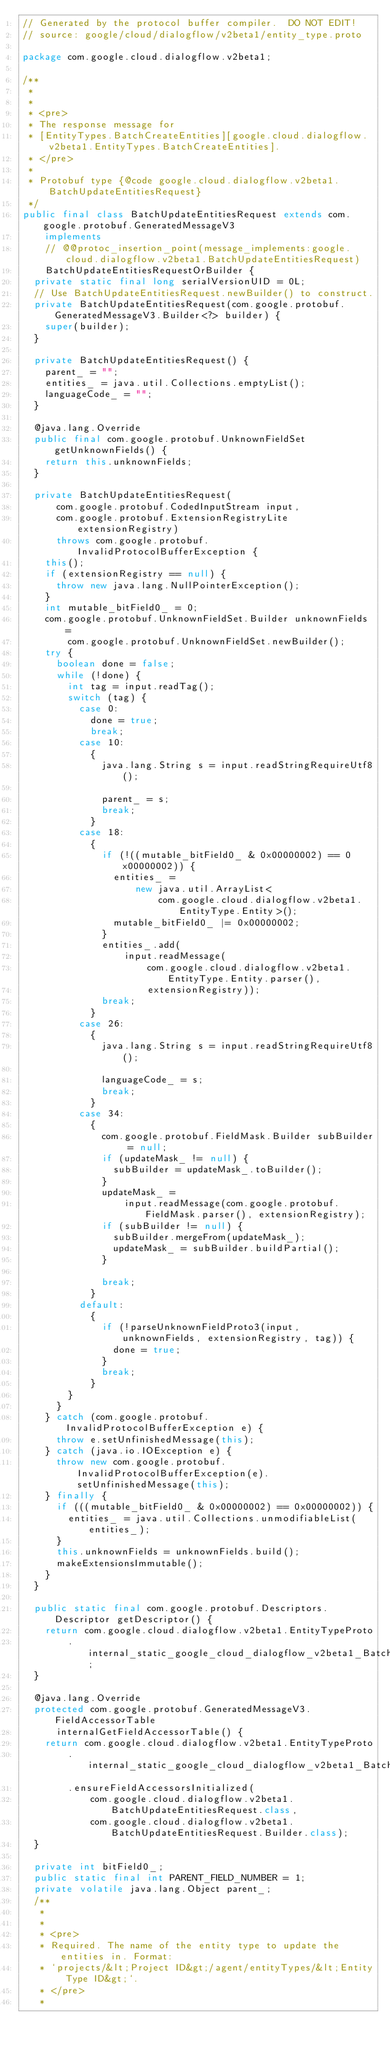Convert code to text. <code><loc_0><loc_0><loc_500><loc_500><_Java_>// Generated by the protocol buffer compiler.  DO NOT EDIT!
// source: google/cloud/dialogflow/v2beta1/entity_type.proto

package com.google.cloud.dialogflow.v2beta1;

/**
 *
 *
 * <pre>
 * The response message for
 * [EntityTypes.BatchCreateEntities][google.cloud.dialogflow.v2beta1.EntityTypes.BatchCreateEntities].
 * </pre>
 *
 * Protobuf type {@code google.cloud.dialogflow.v2beta1.BatchUpdateEntitiesRequest}
 */
public final class BatchUpdateEntitiesRequest extends com.google.protobuf.GeneratedMessageV3
    implements
    // @@protoc_insertion_point(message_implements:google.cloud.dialogflow.v2beta1.BatchUpdateEntitiesRequest)
    BatchUpdateEntitiesRequestOrBuilder {
  private static final long serialVersionUID = 0L;
  // Use BatchUpdateEntitiesRequest.newBuilder() to construct.
  private BatchUpdateEntitiesRequest(com.google.protobuf.GeneratedMessageV3.Builder<?> builder) {
    super(builder);
  }

  private BatchUpdateEntitiesRequest() {
    parent_ = "";
    entities_ = java.util.Collections.emptyList();
    languageCode_ = "";
  }

  @java.lang.Override
  public final com.google.protobuf.UnknownFieldSet getUnknownFields() {
    return this.unknownFields;
  }

  private BatchUpdateEntitiesRequest(
      com.google.protobuf.CodedInputStream input,
      com.google.protobuf.ExtensionRegistryLite extensionRegistry)
      throws com.google.protobuf.InvalidProtocolBufferException {
    this();
    if (extensionRegistry == null) {
      throw new java.lang.NullPointerException();
    }
    int mutable_bitField0_ = 0;
    com.google.protobuf.UnknownFieldSet.Builder unknownFields =
        com.google.protobuf.UnknownFieldSet.newBuilder();
    try {
      boolean done = false;
      while (!done) {
        int tag = input.readTag();
        switch (tag) {
          case 0:
            done = true;
            break;
          case 10:
            {
              java.lang.String s = input.readStringRequireUtf8();

              parent_ = s;
              break;
            }
          case 18:
            {
              if (!((mutable_bitField0_ & 0x00000002) == 0x00000002)) {
                entities_ =
                    new java.util.ArrayList<
                        com.google.cloud.dialogflow.v2beta1.EntityType.Entity>();
                mutable_bitField0_ |= 0x00000002;
              }
              entities_.add(
                  input.readMessage(
                      com.google.cloud.dialogflow.v2beta1.EntityType.Entity.parser(),
                      extensionRegistry));
              break;
            }
          case 26:
            {
              java.lang.String s = input.readStringRequireUtf8();

              languageCode_ = s;
              break;
            }
          case 34:
            {
              com.google.protobuf.FieldMask.Builder subBuilder = null;
              if (updateMask_ != null) {
                subBuilder = updateMask_.toBuilder();
              }
              updateMask_ =
                  input.readMessage(com.google.protobuf.FieldMask.parser(), extensionRegistry);
              if (subBuilder != null) {
                subBuilder.mergeFrom(updateMask_);
                updateMask_ = subBuilder.buildPartial();
              }

              break;
            }
          default:
            {
              if (!parseUnknownFieldProto3(input, unknownFields, extensionRegistry, tag)) {
                done = true;
              }
              break;
            }
        }
      }
    } catch (com.google.protobuf.InvalidProtocolBufferException e) {
      throw e.setUnfinishedMessage(this);
    } catch (java.io.IOException e) {
      throw new com.google.protobuf.InvalidProtocolBufferException(e).setUnfinishedMessage(this);
    } finally {
      if (((mutable_bitField0_ & 0x00000002) == 0x00000002)) {
        entities_ = java.util.Collections.unmodifiableList(entities_);
      }
      this.unknownFields = unknownFields.build();
      makeExtensionsImmutable();
    }
  }

  public static final com.google.protobuf.Descriptors.Descriptor getDescriptor() {
    return com.google.cloud.dialogflow.v2beta1.EntityTypeProto
        .internal_static_google_cloud_dialogflow_v2beta1_BatchUpdateEntitiesRequest_descriptor;
  }

  @java.lang.Override
  protected com.google.protobuf.GeneratedMessageV3.FieldAccessorTable
      internalGetFieldAccessorTable() {
    return com.google.cloud.dialogflow.v2beta1.EntityTypeProto
        .internal_static_google_cloud_dialogflow_v2beta1_BatchUpdateEntitiesRequest_fieldAccessorTable
        .ensureFieldAccessorsInitialized(
            com.google.cloud.dialogflow.v2beta1.BatchUpdateEntitiesRequest.class,
            com.google.cloud.dialogflow.v2beta1.BatchUpdateEntitiesRequest.Builder.class);
  }

  private int bitField0_;
  public static final int PARENT_FIELD_NUMBER = 1;
  private volatile java.lang.Object parent_;
  /**
   *
   *
   * <pre>
   * Required. The name of the entity type to update the entities in. Format:
   * `projects/&lt;Project ID&gt;/agent/entityTypes/&lt;Entity Type ID&gt;`.
   * </pre>
   *</code> 